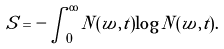Convert formula to latex. <formula><loc_0><loc_0><loc_500><loc_500>S = - \int _ { 0 } ^ { \infty } N ( w , t ) \log { N ( w , t ) } .</formula> 